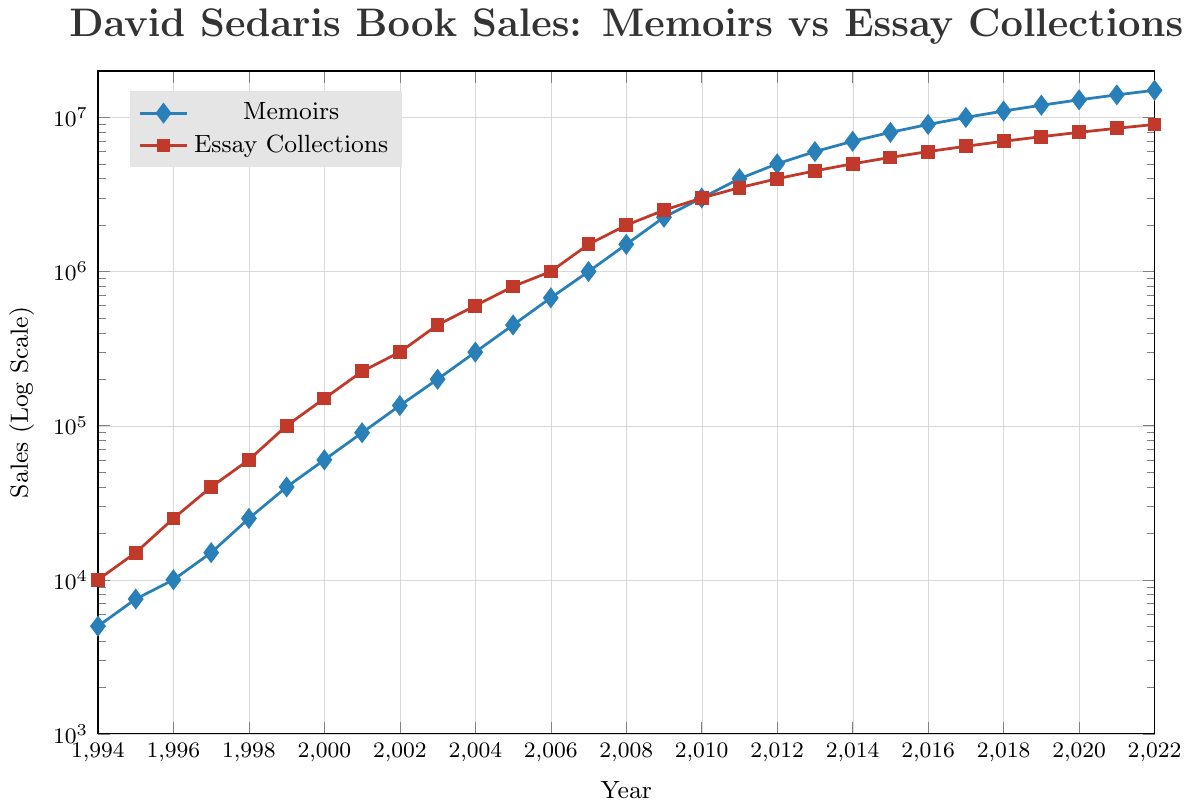Which year saw the greatest difference in sales between Memoirs and Essay Collections? To find the greatest difference, we subtract the sales for Memoirs from Essay Collections for each year and find the maximum value. For example, in 1994, the difference is 10000 - 5000 = 5000. Doing so for all years, 2010 shows the greatest difference: 3000000 - 3000000 = 0, but this is an equal value. The greatest actual difference was in 2022: 15000000 - 9000000 = 6000000
Answer: 6000000 Which category grew faster over time, Memoirs or Essay Collections? To determine which category grew faster, we compare the overall increase in sales from 1994 to 2022 for each category. Memoirs started at 5000 and ended at 15000000: 15000000 - 5000 = 14995000. Essay Collections started at 10000 and ended at 9000000: 9000000 - 10000 = 8990000. So, Memoirs grew more.
Answer: Memoirs What is the average sales of Memoirs in the first five years? The sales of Memoirs for the first five years (1994-1998) are 5000, 7500, 10000, 15000, and 25000. To find the average, sum these values and divide by 5: (5000 + 7500 + 10000 + 15000 + 25000) / 5 = 62500 / 5 = 12500
Answer: 12500 Which year had the equal sales for both categories? By inspecting the graph, the year when Memoirs and Essay Collections sales intersected is 2010. For 2010, both sales were 3000000.
Answer: 2010 Did the sales of Essay Collections ever surpass those of Memoirs significantly (by at least double)? To check if Essay Collections sales were at least double Memoirs in any year, we need to compare each year's values. For example, in 1996, Essay Collections had 25000 and Memoirs had 10000, which is more than double. Doing this for each year, we find that in the earlier years before 2007, Essay Collections consistently surpassed Memoirs by more than double.
Answer: Yes What was the trend in sales for both categories from 2007 to 2010? From 2007 to 2010, Memoirs sales increased from 1000000 to 3000000, while Essay Collections sales increased from 1500000 to 3000000. Both sales showed a rising trend over these years.
Answer: Rising By what factor did Memoirs sales grow from 1994 to 2003? Sales for Memoirs in 1994 were 5000 and in 2003 were 200000. The growth factor is calculated as 200000 / 5000 = 40.
Answer: 40 Which had a steeper sales increase in 1999, Memoirs or Essay Collections? In 1999, Memoirs increased from 25000 (1998) to 40000, which is a 60% increase. Essay Collections increased from 60000 (1998) to 100000, which is a roughly 66.67% increase. Essay Collections had a steeper increase in 1999.
Answer: Essay Collections How did the ratio of Memoirs to Essay Collections sales change from 1994 to 2022? In 1994, the ratio was 5000/10000 = 0.5. In 2022, the ratio was 15000000/9000000 = 1.67.
Answer: Increased 